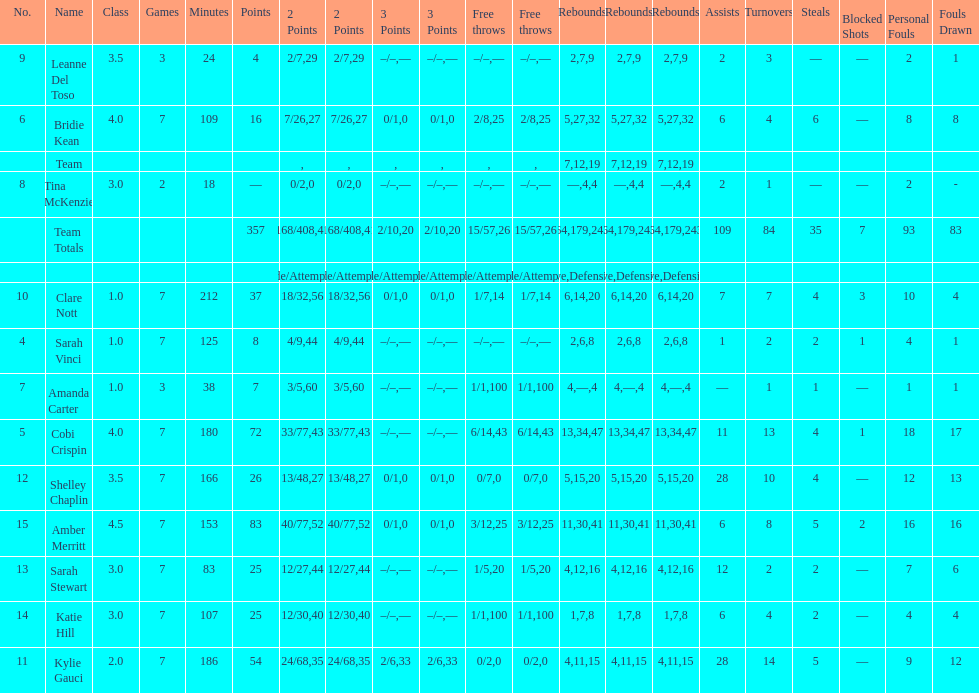Number of 3 points attempted 10. 